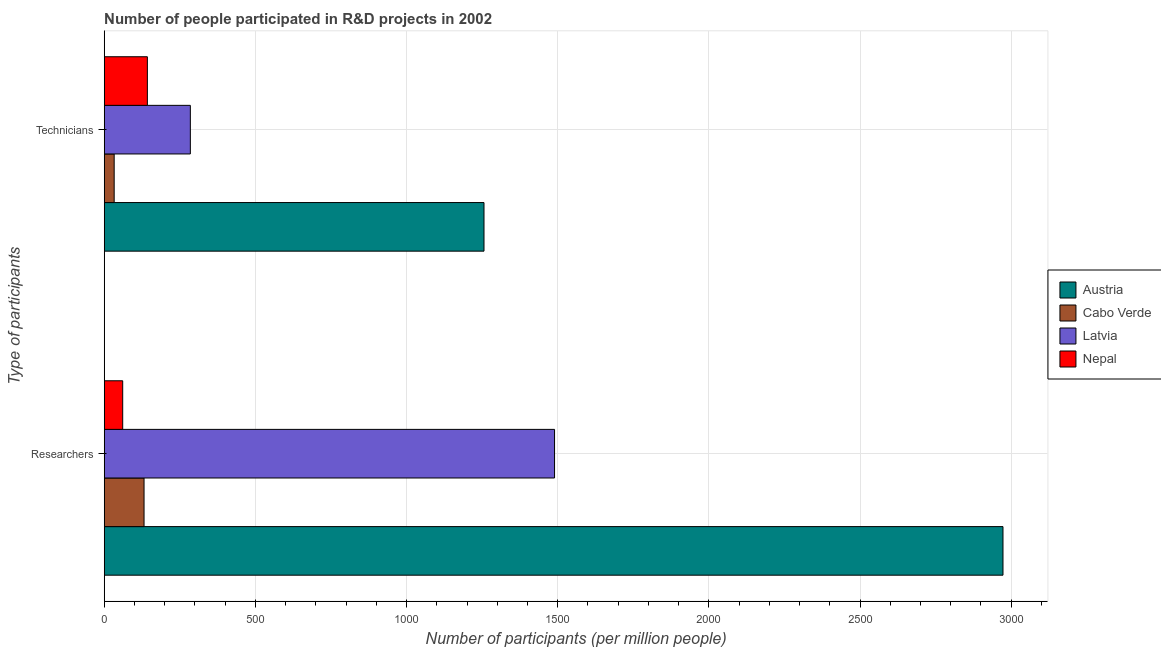How many bars are there on the 1st tick from the top?
Ensure brevity in your answer.  4. How many bars are there on the 1st tick from the bottom?
Your response must be concise. 4. What is the label of the 1st group of bars from the top?
Provide a succinct answer. Technicians. What is the number of researchers in Cabo Verde?
Provide a succinct answer. 131.75. Across all countries, what is the maximum number of technicians?
Your response must be concise. 1256.23. Across all countries, what is the minimum number of technicians?
Make the answer very short. 32.94. In which country was the number of technicians maximum?
Offer a terse response. Austria. In which country was the number of researchers minimum?
Offer a terse response. Nepal. What is the total number of technicians in the graph?
Give a very brief answer. 1716.81. What is the difference between the number of technicians in Nepal and that in Latvia?
Your response must be concise. -142.13. What is the difference between the number of researchers in Cabo Verde and the number of technicians in Nepal?
Offer a terse response. -11. What is the average number of researchers per country?
Your answer should be very brief. 1163.86. What is the difference between the number of researchers and number of technicians in Austria?
Your answer should be very brief. 1716.66. What is the ratio of the number of researchers in Austria to that in Cabo Verde?
Provide a short and direct response. 22.56. What does the 4th bar from the bottom in Researchers represents?
Keep it short and to the point. Nepal. Are all the bars in the graph horizontal?
Provide a short and direct response. Yes. Are the values on the major ticks of X-axis written in scientific E-notation?
Make the answer very short. No. Where does the legend appear in the graph?
Keep it short and to the point. Center right. What is the title of the graph?
Make the answer very short. Number of people participated in R&D projects in 2002. Does "Algeria" appear as one of the legend labels in the graph?
Offer a terse response. No. What is the label or title of the X-axis?
Your response must be concise. Number of participants (per million people). What is the label or title of the Y-axis?
Offer a terse response. Type of participants. What is the Number of participants (per million people) of Austria in Researchers?
Offer a very short reply. 2972.89. What is the Number of participants (per million people) in Cabo Verde in Researchers?
Offer a very short reply. 131.75. What is the Number of participants (per million people) in Latvia in Researchers?
Provide a short and direct response. 1489.6. What is the Number of participants (per million people) in Nepal in Researchers?
Your answer should be compact. 61.18. What is the Number of participants (per million people) of Austria in Technicians?
Provide a succinct answer. 1256.23. What is the Number of participants (per million people) in Cabo Verde in Technicians?
Offer a very short reply. 32.94. What is the Number of participants (per million people) of Latvia in Technicians?
Your answer should be compact. 284.88. What is the Number of participants (per million people) of Nepal in Technicians?
Your response must be concise. 142.76. Across all Type of participants, what is the maximum Number of participants (per million people) in Austria?
Offer a very short reply. 2972.89. Across all Type of participants, what is the maximum Number of participants (per million people) of Cabo Verde?
Keep it short and to the point. 131.75. Across all Type of participants, what is the maximum Number of participants (per million people) in Latvia?
Your answer should be very brief. 1489.6. Across all Type of participants, what is the maximum Number of participants (per million people) in Nepal?
Provide a succinct answer. 142.76. Across all Type of participants, what is the minimum Number of participants (per million people) of Austria?
Keep it short and to the point. 1256.23. Across all Type of participants, what is the minimum Number of participants (per million people) in Cabo Verde?
Keep it short and to the point. 32.94. Across all Type of participants, what is the minimum Number of participants (per million people) of Latvia?
Keep it short and to the point. 284.88. Across all Type of participants, what is the minimum Number of participants (per million people) of Nepal?
Give a very brief answer. 61.18. What is the total Number of participants (per million people) of Austria in the graph?
Your answer should be compact. 4229.12. What is the total Number of participants (per million people) of Cabo Verde in the graph?
Ensure brevity in your answer.  164.69. What is the total Number of participants (per million people) of Latvia in the graph?
Ensure brevity in your answer.  1774.48. What is the total Number of participants (per million people) in Nepal in the graph?
Make the answer very short. 203.94. What is the difference between the Number of participants (per million people) of Austria in Researchers and that in Technicians?
Provide a short and direct response. 1716.66. What is the difference between the Number of participants (per million people) of Cabo Verde in Researchers and that in Technicians?
Give a very brief answer. 98.82. What is the difference between the Number of participants (per million people) of Latvia in Researchers and that in Technicians?
Ensure brevity in your answer.  1204.71. What is the difference between the Number of participants (per million people) of Nepal in Researchers and that in Technicians?
Your answer should be compact. -81.58. What is the difference between the Number of participants (per million people) in Austria in Researchers and the Number of participants (per million people) in Cabo Verde in Technicians?
Provide a short and direct response. 2939.95. What is the difference between the Number of participants (per million people) in Austria in Researchers and the Number of participants (per million people) in Latvia in Technicians?
Keep it short and to the point. 2688.01. What is the difference between the Number of participants (per million people) of Austria in Researchers and the Number of participants (per million people) of Nepal in Technicians?
Your response must be concise. 2830.13. What is the difference between the Number of participants (per million people) of Cabo Verde in Researchers and the Number of participants (per million people) of Latvia in Technicians?
Ensure brevity in your answer.  -153.13. What is the difference between the Number of participants (per million people) of Cabo Verde in Researchers and the Number of participants (per million people) of Nepal in Technicians?
Keep it short and to the point. -11. What is the difference between the Number of participants (per million people) in Latvia in Researchers and the Number of participants (per million people) in Nepal in Technicians?
Keep it short and to the point. 1346.84. What is the average Number of participants (per million people) in Austria per Type of participants?
Make the answer very short. 2114.56. What is the average Number of participants (per million people) of Cabo Verde per Type of participants?
Provide a short and direct response. 82.35. What is the average Number of participants (per million people) of Latvia per Type of participants?
Make the answer very short. 887.24. What is the average Number of participants (per million people) of Nepal per Type of participants?
Make the answer very short. 101.97. What is the difference between the Number of participants (per million people) in Austria and Number of participants (per million people) in Cabo Verde in Researchers?
Your response must be concise. 2841.14. What is the difference between the Number of participants (per million people) of Austria and Number of participants (per million people) of Latvia in Researchers?
Offer a terse response. 1483.29. What is the difference between the Number of participants (per million people) of Austria and Number of participants (per million people) of Nepal in Researchers?
Your answer should be very brief. 2911.71. What is the difference between the Number of participants (per million people) of Cabo Verde and Number of participants (per million people) of Latvia in Researchers?
Provide a short and direct response. -1357.85. What is the difference between the Number of participants (per million people) of Cabo Verde and Number of participants (per million people) of Nepal in Researchers?
Keep it short and to the point. 70.57. What is the difference between the Number of participants (per million people) in Latvia and Number of participants (per million people) in Nepal in Researchers?
Keep it short and to the point. 1428.42. What is the difference between the Number of participants (per million people) of Austria and Number of participants (per million people) of Cabo Verde in Technicians?
Make the answer very short. 1223.29. What is the difference between the Number of participants (per million people) of Austria and Number of participants (per million people) of Latvia in Technicians?
Provide a short and direct response. 971.34. What is the difference between the Number of participants (per million people) in Austria and Number of participants (per million people) in Nepal in Technicians?
Keep it short and to the point. 1113.47. What is the difference between the Number of participants (per million people) in Cabo Verde and Number of participants (per million people) in Latvia in Technicians?
Make the answer very short. -251.95. What is the difference between the Number of participants (per million people) of Cabo Verde and Number of participants (per million people) of Nepal in Technicians?
Your answer should be very brief. -109.82. What is the difference between the Number of participants (per million people) in Latvia and Number of participants (per million people) in Nepal in Technicians?
Your answer should be compact. 142.13. What is the ratio of the Number of participants (per million people) in Austria in Researchers to that in Technicians?
Offer a terse response. 2.37. What is the ratio of the Number of participants (per million people) in Latvia in Researchers to that in Technicians?
Offer a very short reply. 5.23. What is the ratio of the Number of participants (per million people) of Nepal in Researchers to that in Technicians?
Provide a succinct answer. 0.43. What is the difference between the highest and the second highest Number of participants (per million people) of Austria?
Your response must be concise. 1716.66. What is the difference between the highest and the second highest Number of participants (per million people) of Cabo Verde?
Keep it short and to the point. 98.82. What is the difference between the highest and the second highest Number of participants (per million people) in Latvia?
Offer a terse response. 1204.71. What is the difference between the highest and the second highest Number of participants (per million people) in Nepal?
Offer a terse response. 81.58. What is the difference between the highest and the lowest Number of participants (per million people) of Austria?
Provide a short and direct response. 1716.66. What is the difference between the highest and the lowest Number of participants (per million people) of Cabo Verde?
Provide a short and direct response. 98.82. What is the difference between the highest and the lowest Number of participants (per million people) of Latvia?
Ensure brevity in your answer.  1204.71. What is the difference between the highest and the lowest Number of participants (per million people) of Nepal?
Your answer should be very brief. 81.58. 